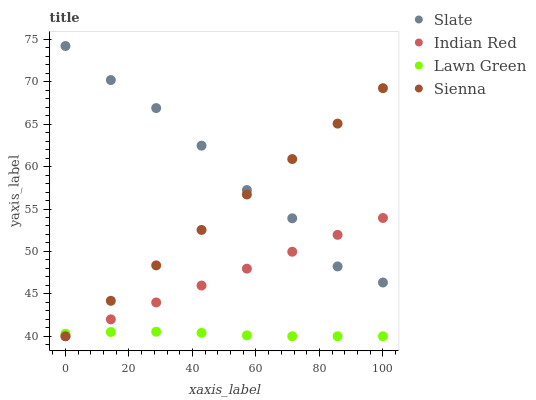Does Lawn Green have the minimum area under the curve?
Answer yes or no. Yes. Does Slate have the maximum area under the curve?
Answer yes or no. Yes. Does Slate have the minimum area under the curve?
Answer yes or no. No. Does Lawn Green have the maximum area under the curve?
Answer yes or no. No. Is Sienna the smoothest?
Answer yes or no. Yes. Is Slate the roughest?
Answer yes or no. Yes. Is Lawn Green the smoothest?
Answer yes or no. No. Is Lawn Green the roughest?
Answer yes or no. No. Does Sienna have the lowest value?
Answer yes or no. Yes. Does Slate have the lowest value?
Answer yes or no. No. Does Slate have the highest value?
Answer yes or no. Yes. Does Lawn Green have the highest value?
Answer yes or no. No. Is Lawn Green less than Slate?
Answer yes or no. Yes. Is Slate greater than Lawn Green?
Answer yes or no. Yes. Does Slate intersect Indian Red?
Answer yes or no. Yes. Is Slate less than Indian Red?
Answer yes or no. No. Is Slate greater than Indian Red?
Answer yes or no. No. Does Lawn Green intersect Slate?
Answer yes or no. No. 